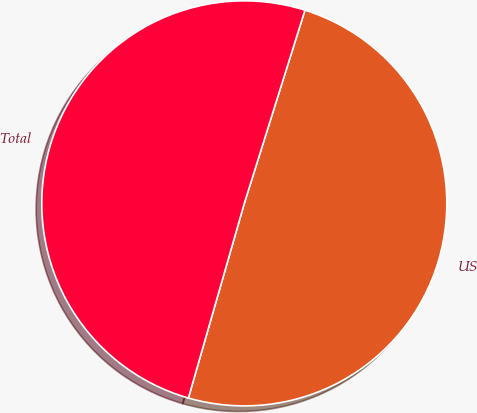<chart> <loc_0><loc_0><loc_500><loc_500><pie_chart><fcel>US<fcel>Total<nl><fcel>49.61%<fcel>50.39%<nl></chart> 